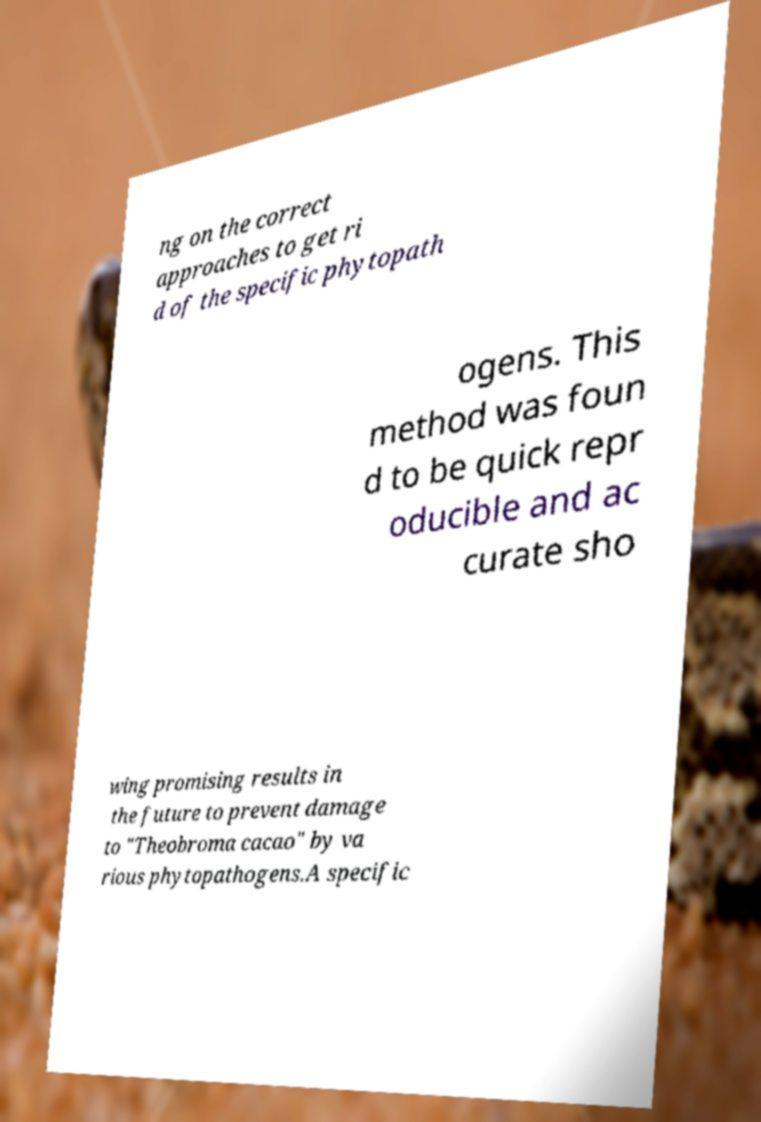Please read and relay the text visible in this image. What does it say? ng on the correct approaches to get ri d of the specific phytopath ogens. This method was foun d to be quick repr oducible and ac curate sho wing promising results in the future to prevent damage to "Theobroma cacao" by va rious phytopathogens.A specific 